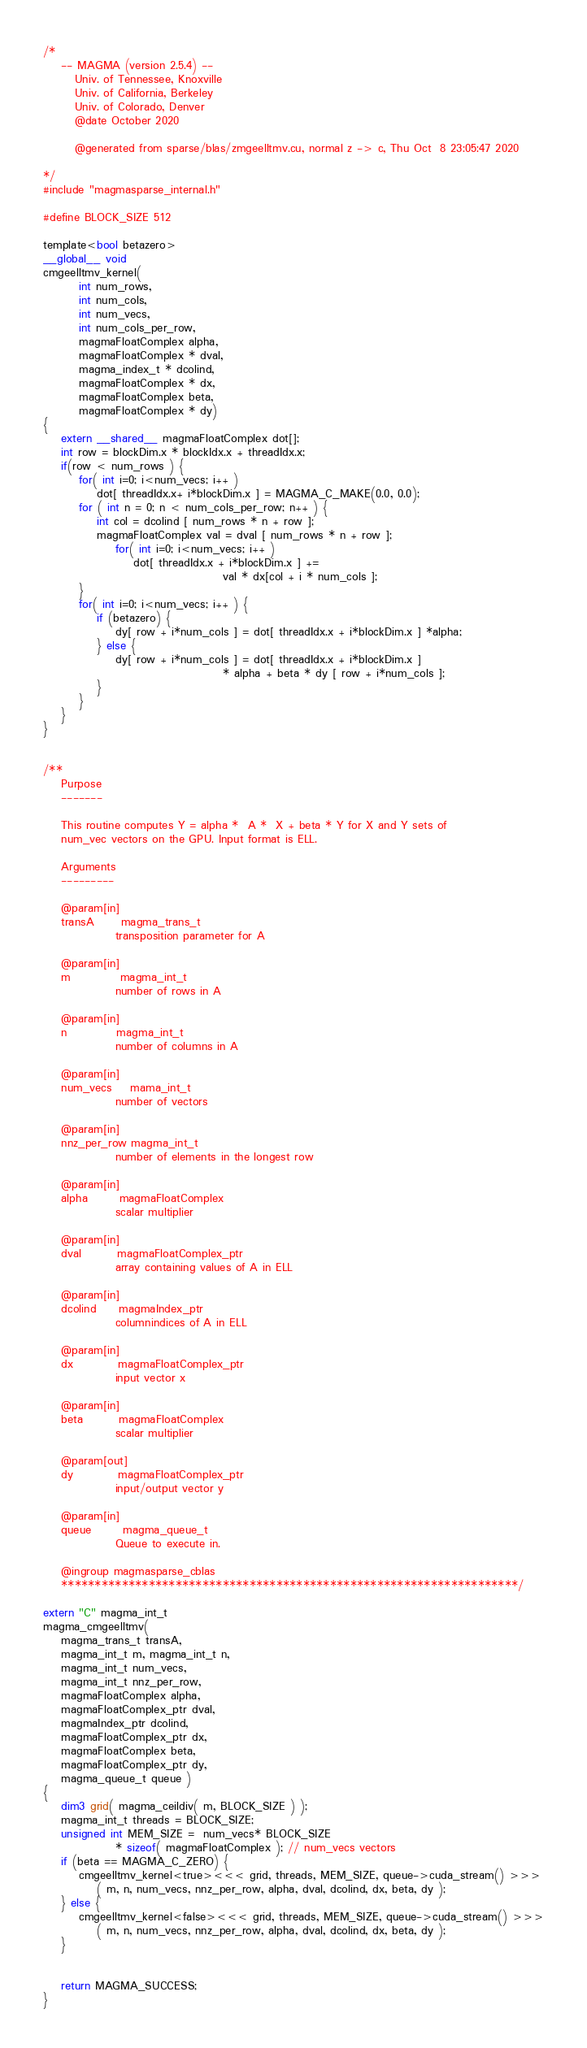<code> <loc_0><loc_0><loc_500><loc_500><_Cuda_>/*
    -- MAGMA (version 2.5.4) --
       Univ. of Tennessee, Knoxville
       Univ. of California, Berkeley
       Univ. of Colorado, Denver
       @date October 2020

       @generated from sparse/blas/zmgeelltmv.cu, normal z -> c, Thu Oct  8 23:05:47 2020

*/
#include "magmasparse_internal.h"

#define BLOCK_SIZE 512

template<bool betazero>
__global__ void 
cmgeelltmv_kernel( 
        int num_rows, 
        int num_cols,
        int num_vecs,
        int num_cols_per_row,
        magmaFloatComplex alpha, 
        magmaFloatComplex * dval, 
        magma_index_t * dcolind,
        magmaFloatComplex * dx,
        magmaFloatComplex beta, 
        magmaFloatComplex * dy)
{
    extern __shared__ magmaFloatComplex dot[];
    int row = blockDim.x * blockIdx.x + threadIdx.x;
    if(row < num_rows ) {
        for( int i=0; i<num_vecs; i++ )
            dot[ threadIdx.x+ i*blockDim.x ] = MAGMA_C_MAKE(0.0, 0.0);
        for ( int n = 0; n < num_cols_per_row; n++ ) {
            int col = dcolind [ num_rows * n + row ];
            magmaFloatComplex val = dval [ num_rows * n + row ];
                for( int i=0; i<num_vecs; i++ )
                    dot[ threadIdx.x + i*blockDim.x ] += 
                                        val * dx[col + i * num_cols ];
        }
        for( int i=0; i<num_vecs; i++ ) {
            if (betazero) {
                dy[ row + i*num_cols ] = dot[ threadIdx.x + i*blockDim.x ] *alpha;
            } else {
                dy[ row + i*num_cols ] = dot[ threadIdx.x + i*blockDim.x ] 
                                        * alpha + beta * dy [ row + i*num_cols ];
            }
        }
    }
}


/**
    Purpose
    -------
    
    This routine computes Y = alpha *  A *  X + beta * Y for X and Y sets of 
    num_vec vectors on the GPU. Input format is ELL. 
    
    Arguments
    ---------

    @param[in]
    transA      magma_trans_t
                transposition parameter for A

    @param[in]
    m           magma_int_t
                number of rows in A

    @param[in]
    n           magma_int_t
                number of columns in A 
                
    @param[in]
    num_vecs    mama_int_t
                number of vectors
                
    @param[in]
    nnz_per_row magma_int_t
                number of elements in the longest row 
                
    @param[in]
    alpha       magmaFloatComplex
                scalar multiplier

    @param[in]
    dval        magmaFloatComplex_ptr
                array containing values of A in ELL

    @param[in]
    dcolind     magmaIndex_ptr
                columnindices of A in ELL

    @param[in]
    dx          magmaFloatComplex_ptr
                input vector x

    @param[in]
    beta        magmaFloatComplex
                scalar multiplier

    @param[out]
    dy          magmaFloatComplex_ptr
                input/output vector y

    @param[in]
    queue       magma_queue_t
                Queue to execute in.

    @ingroup magmasparse_cblas
    ********************************************************************/

extern "C" magma_int_t
magma_cmgeelltmv(
    magma_trans_t transA,
    magma_int_t m, magma_int_t n,
    magma_int_t num_vecs,
    magma_int_t nnz_per_row,
    magmaFloatComplex alpha,
    magmaFloatComplex_ptr dval,
    magmaIndex_ptr dcolind,
    magmaFloatComplex_ptr dx,
    magmaFloatComplex beta,
    magmaFloatComplex_ptr dy,
    magma_queue_t queue )
{
    dim3 grid( magma_ceildiv( m, BLOCK_SIZE ) );
    magma_int_t threads = BLOCK_SIZE;
    unsigned int MEM_SIZE =  num_vecs* BLOCK_SIZE 
                * sizeof( magmaFloatComplex ); // num_vecs vectors 
    if (beta == MAGMA_C_ZERO) {
        cmgeelltmv_kernel<true><<< grid, threads, MEM_SIZE, queue->cuda_stream() >>>
            ( m, n, num_vecs, nnz_per_row, alpha, dval, dcolind, dx, beta, dy );
    } else {
        cmgeelltmv_kernel<false><<< grid, threads, MEM_SIZE, queue->cuda_stream() >>>
            ( m, n, num_vecs, nnz_per_row, alpha, dval, dcolind, dx, beta, dy );
    }


    return MAGMA_SUCCESS;
}
</code> 